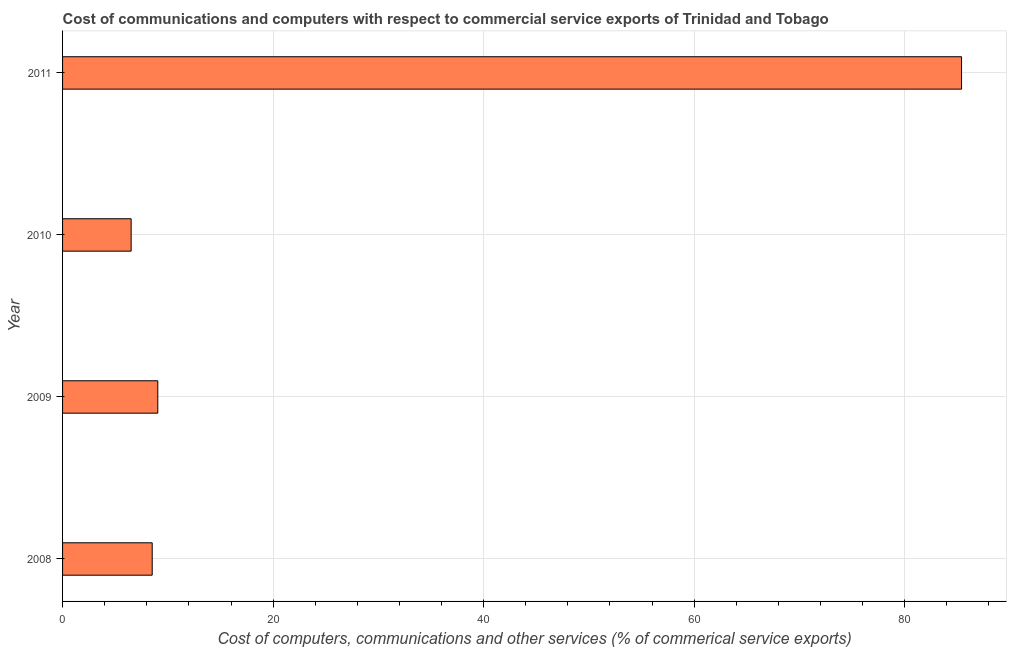What is the title of the graph?
Offer a very short reply. Cost of communications and computers with respect to commercial service exports of Trinidad and Tobago. What is the label or title of the X-axis?
Keep it short and to the point. Cost of computers, communications and other services (% of commerical service exports). What is the cost of communications in 2010?
Your response must be concise. 6.51. Across all years, what is the maximum  computer and other services?
Keep it short and to the point. 85.4. Across all years, what is the minimum cost of communications?
Provide a short and direct response. 6.51. In which year was the  computer and other services maximum?
Give a very brief answer. 2011. What is the sum of the cost of communications?
Offer a terse response. 109.47. What is the difference between the  computer and other services in 2010 and 2011?
Offer a very short reply. -78.88. What is the average  computer and other services per year?
Make the answer very short. 27.37. What is the median cost of communications?
Ensure brevity in your answer.  8.78. In how many years, is the  computer and other services greater than 4 %?
Give a very brief answer. 4. What is the ratio of the  computer and other services in 2008 to that in 2010?
Provide a succinct answer. 1.31. Is the  computer and other services in 2008 less than that in 2010?
Provide a succinct answer. No. What is the difference between the highest and the second highest cost of communications?
Your answer should be compact. 76.35. Is the sum of the cost of communications in 2008 and 2011 greater than the maximum cost of communications across all years?
Make the answer very short. Yes. What is the difference between the highest and the lowest  computer and other services?
Ensure brevity in your answer.  78.88. In how many years, is the cost of communications greater than the average cost of communications taken over all years?
Provide a succinct answer. 1. How many bars are there?
Give a very brief answer. 4. How many years are there in the graph?
Provide a short and direct response. 4. What is the difference between two consecutive major ticks on the X-axis?
Ensure brevity in your answer.  20. What is the Cost of computers, communications and other services (% of commerical service exports) of 2008?
Offer a terse response. 8.52. What is the Cost of computers, communications and other services (% of commerical service exports) in 2009?
Keep it short and to the point. 9.05. What is the Cost of computers, communications and other services (% of commerical service exports) of 2010?
Your response must be concise. 6.51. What is the Cost of computers, communications and other services (% of commerical service exports) of 2011?
Keep it short and to the point. 85.4. What is the difference between the Cost of computers, communications and other services (% of commerical service exports) in 2008 and 2009?
Make the answer very short. -0.53. What is the difference between the Cost of computers, communications and other services (% of commerical service exports) in 2008 and 2010?
Provide a succinct answer. 2. What is the difference between the Cost of computers, communications and other services (% of commerical service exports) in 2008 and 2011?
Your answer should be very brief. -76.88. What is the difference between the Cost of computers, communications and other services (% of commerical service exports) in 2009 and 2010?
Offer a very short reply. 2.53. What is the difference between the Cost of computers, communications and other services (% of commerical service exports) in 2009 and 2011?
Offer a very short reply. -76.35. What is the difference between the Cost of computers, communications and other services (% of commerical service exports) in 2010 and 2011?
Your answer should be very brief. -78.88. What is the ratio of the Cost of computers, communications and other services (% of commerical service exports) in 2008 to that in 2009?
Provide a succinct answer. 0.94. What is the ratio of the Cost of computers, communications and other services (% of commerical service exports) in 2008 to that in 2010?
Provide a short and direct response. 1.31. What is the ratio of the Cost of computers, communications and other services (% of commerical service exports) in 2008 to that in 2011?
Your response must be concise. 0.1. What is the ratio of the Cost of computers, communications and other services (% of commerical service exports) in 2009 to that in 2010?
Your response must be concise. 1.39. What is the ratio of the Cost of computers, communications and other services (% of commerical service exports) in 2009 to that in 2011?
Your answer should be very brief. 0.11. What is the ratio of the Cost of computers, communications and other services (% of commerical service exports) in 2010 to that in 2011?
Offer a very short reply. 0.08. 